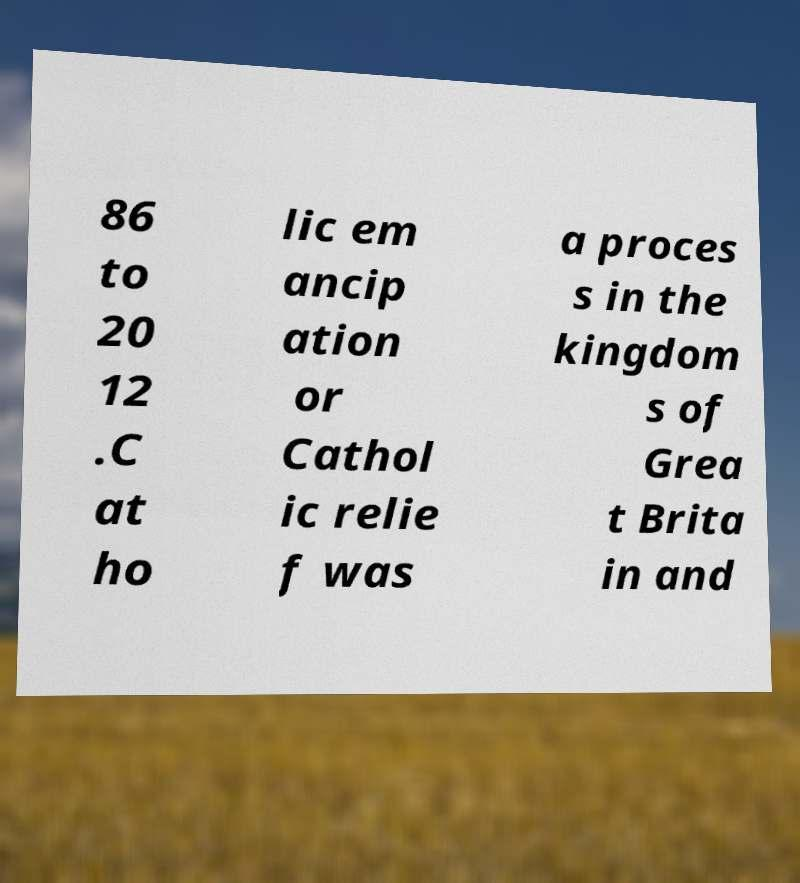Can you accurately transcribe the text from the provided image for me? 86 to 20 12 .C at ho lic em ancip ation or Cathol ic relie f was a proces s in the kingdom s of Grea t Brita in and 